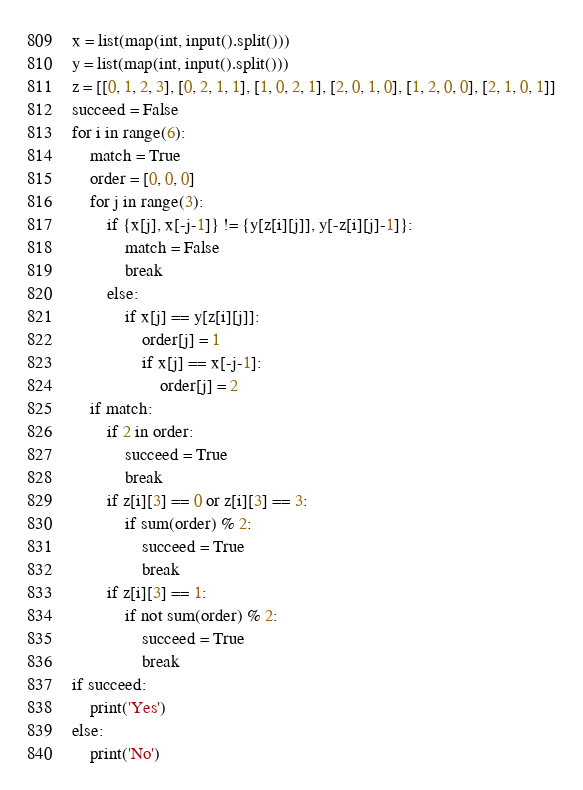Convert code to text. <code><loc_0><loc_0><loc_500><loc_500><_Python_>x = list(map(int, input().split()))
y = list(map(int, input().split()))
z = [[0, 1, 2, 3], [0, 2, 1, 1], [1, 0, 2, 1], [2, 0, 1, 0], [1, 2, 0, 0], [2, 1, 0, 1]]
succeed = False
for i in range(6):
    match = True
    order = [0, 0, 0]
    for j in range(3):
        if {x[j], x[-j-1]} != {y[z[i][j]], y[-z[i][j]-1]}:
            match = False
            break
        else:
            if x[j] == y[z[i][j]]:
                order[j] = 1
                if x[j] == x[-j-1]:
                    order[j] = 2
    if match:
        if 2 in order:
            succeed = True
            break
        if z[i][3] == 0 or z[i][3] == 3:
            if sum(order) % 2:
                succeed = True
                break
        if z[i][3] == 1:
            if not sum(order) % 2:
                succeed = True
                break
if succeed:
    print('Yes')
else:
    print('No')</code> 